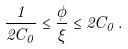<formula> <loc_0><loc_0><loc_500><loc_500>\frac { 1 } { 2 C _ { 0 } } \leq \frac { \phi } { \xi } \leq 2 C _ { 0 } \, .</formula> 